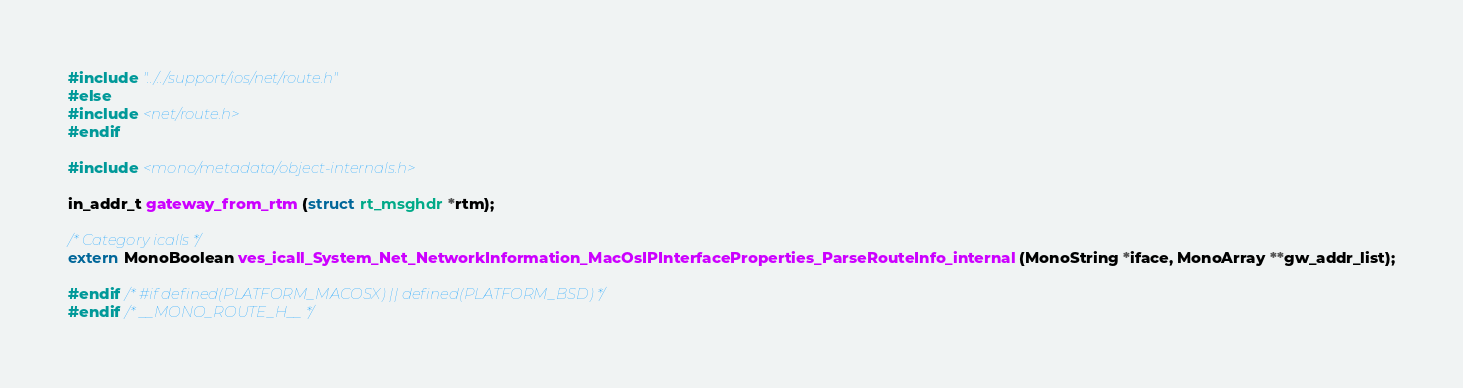<code> <loc_0><loc_0><loc_500><loc_500><_C_>#include "../../support/ios/net/route.h"
#else
#include <net/route.h>
#endif

#include <mono/metadata/object-internals.h>

in_addr_t gateway_from_rtm (struct rt_msghdr *rtm);

/* Category icalls */
extern MonoBoolean ves_icall_System_Net_NetworkInformation_MacOsIPInterfaceProperties_ParseRouteInfo_internal (MonoString *iface, MonoArray **gw_addr_list);

#endif /* #if defined(PLATFORM_MACOSX) || defined(PLATFORM_BSD) */
#endif /* __MONO_ROUTE_H__ */
</code> 